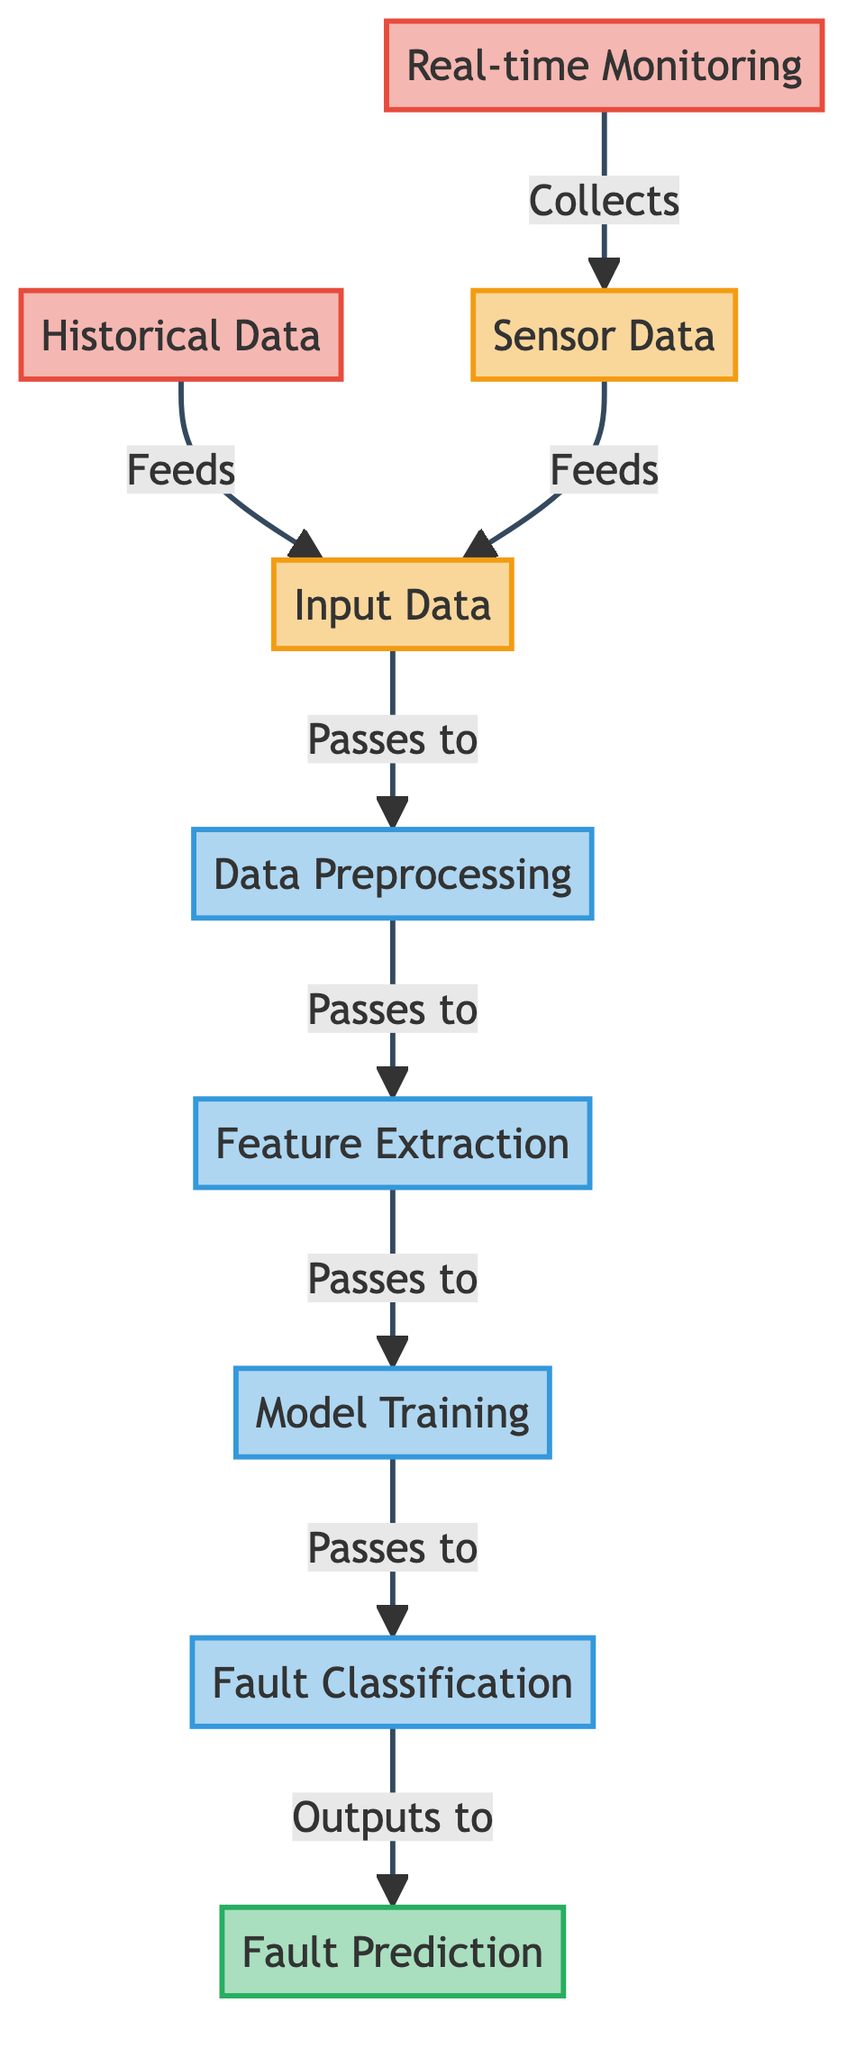What is the first step in the real-time diagnosis process? The first step in the diagram is "Real-time Monitoring," which is depicted as the starting point. It collects sensor data directly and establishes the flow.
Answer: Real-time Monitoring How many inputs are present in the diagram? The diagram contains two inputs: "Historical Data" and "Input Data." These are represented at the top and feed into the subsequent processes.
Answer: Two What does the "Data Preprocessing" node pass data to? The "Data Preprocessing" node passes data to the "Feature Extraction" node, which is its direct next step in the flow.
Answer: Feature Extraction Which element feeds into "Input Data"? Both "Historical Data" and "Sensor Data" feed into "Input Data," indicating that it collects information from two data sources.
Answer: Historical Data, Sensor Data What is the final output of the process? The final output of the diagram is "Fault Prediction," which is the last node displaying the result of the classification process.
Answer: Fault Prediction How many processing nodes are shown in the diagram? There are four processing nodes represented in the diagram: "Data Preprocessing," "Feature Extraction," "Model Training," and "Fault Classification."
Answer: Four What type of data does the "Sensor Data" node represent? The "Sensor Data" node represents real-time data collected from various sensors in the TV, crucial for fault detection and monitoring.
Answer: Real-time data What is the relationship between "Feature Extraction" and "Model Training"? "Feature Extraction" feeds into "Model Training," indicating that the features selected from the data are used as input for training the model.
Answer: Feeds into Which node collects data from the monitoring system? The "Real-time Monitoring" node collects data from the monitoring system, which is the starting point for gathering real-time information.
Answer: Real-time Monitoring 